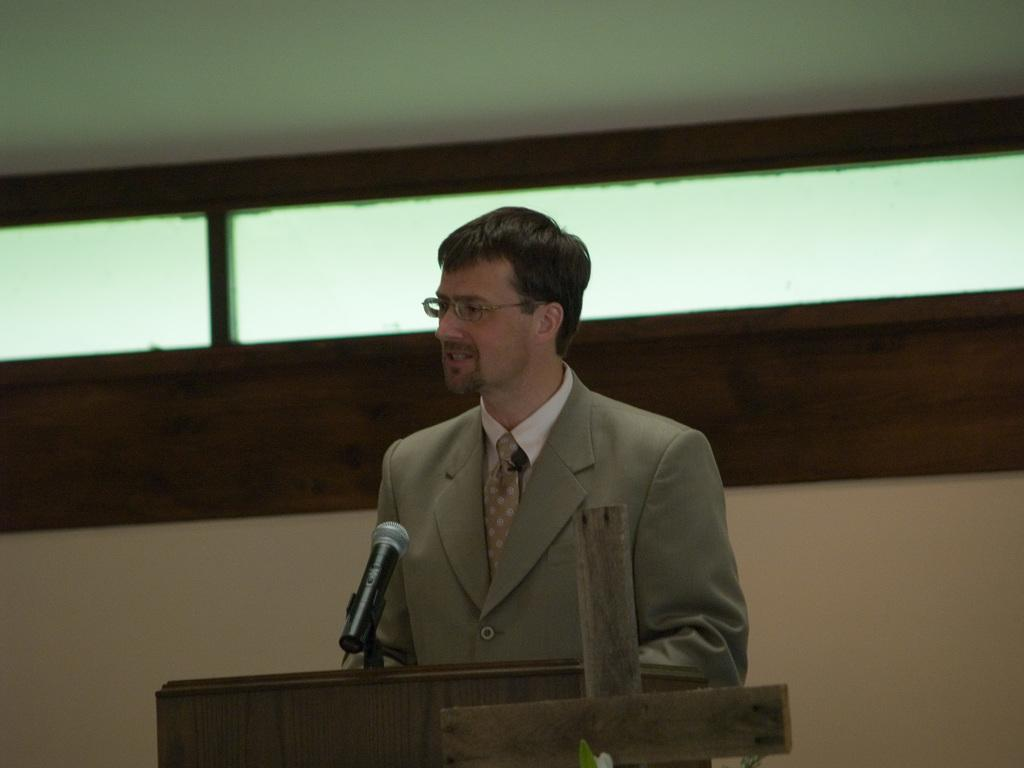Who is the main subject in the image? There is a man in the image. What is the man doing in the image? The man is standing in front of a podium. What is the man wearing in the image? The man is wearing a coat and spectacles. What object is on the podium? There is a microphone on the podium. What can be seen in the background of the image? There is a wall in the background of the image. What is the price of the basketball in the image? There is no basketball present in the image, so it is not possible to determine its price. How does the man's voice sound in the image? The image is a still photograph, so it does not capture sound or the man's voice. 